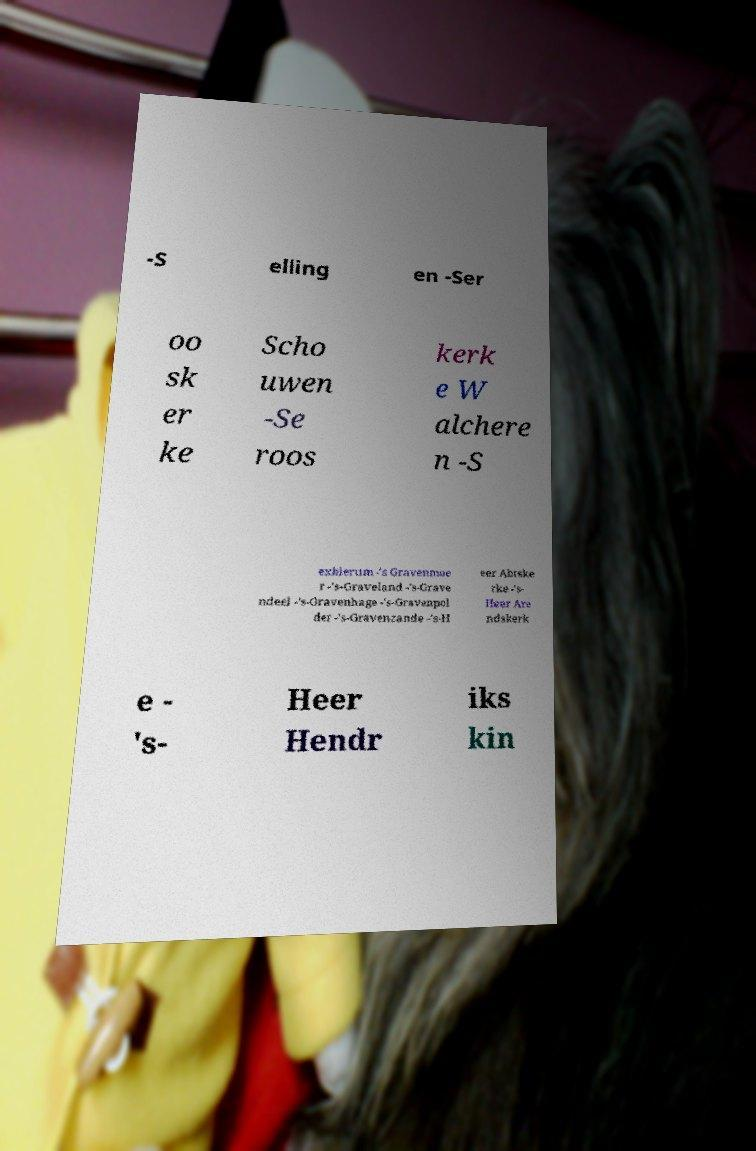What messages or text are displayed in this image? I need them in a readable, typed format. -S elling en -Ser oo sk er ke Scho uwen -Se roos kerk e W alchere n -S exbierum -'s Gravenmoe r -'s-Graveland -'s-Grave ndeel -'s-Gravenhage -'s-Gravenpol der -'s-Gravenzande -'s-H eer Abtske rke -'s- Heer Are ndskerk e - 's- Heer Hendr iks kin 